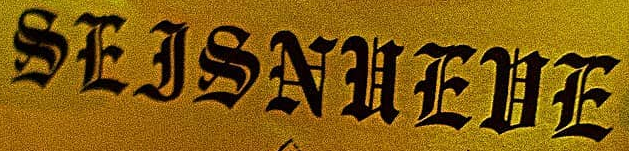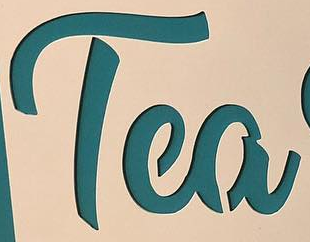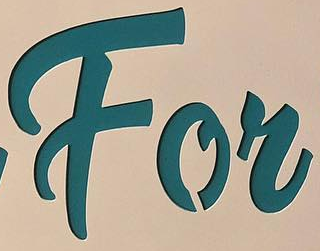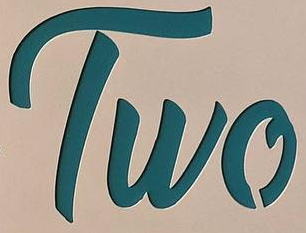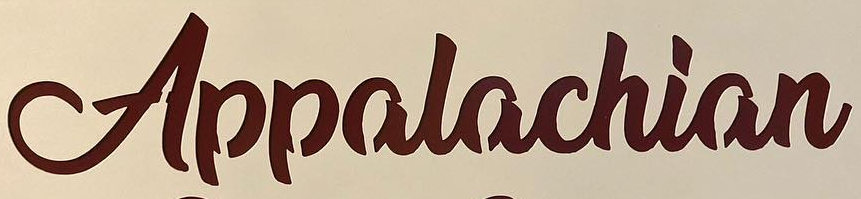Read the text from these images in sequence, separated by a semicolon. SEJSNUEUE; Tea; For; Two; Appalachian 